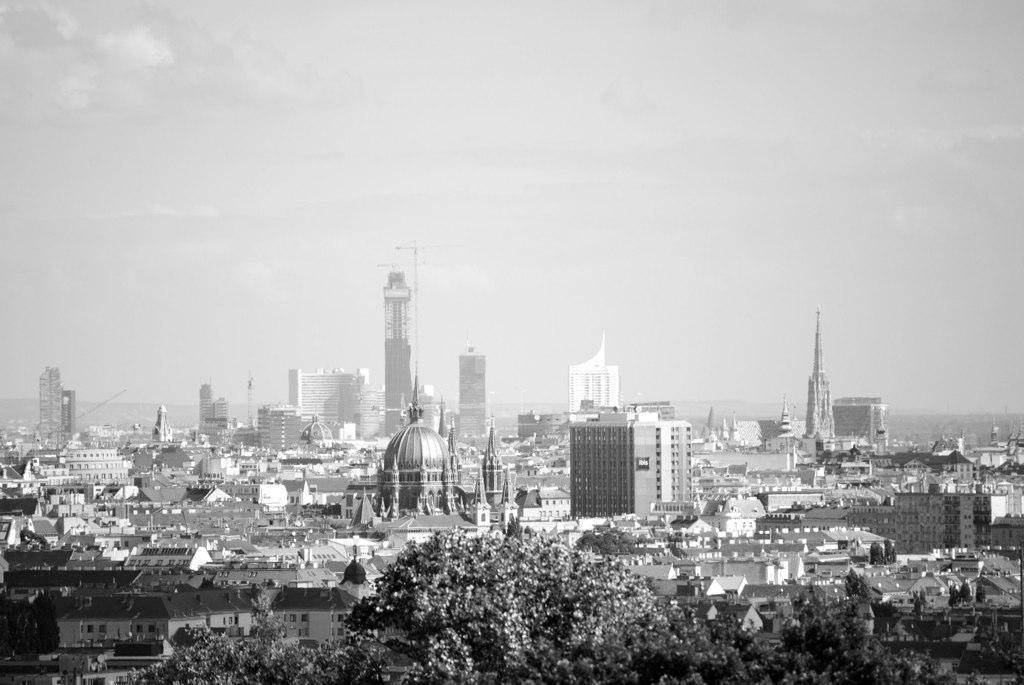In one or two sentences, can you explain what this image depicts? This picture is in black and white. At the bottom, there are buildings and trees. On the top, there is a sky with clouds. 